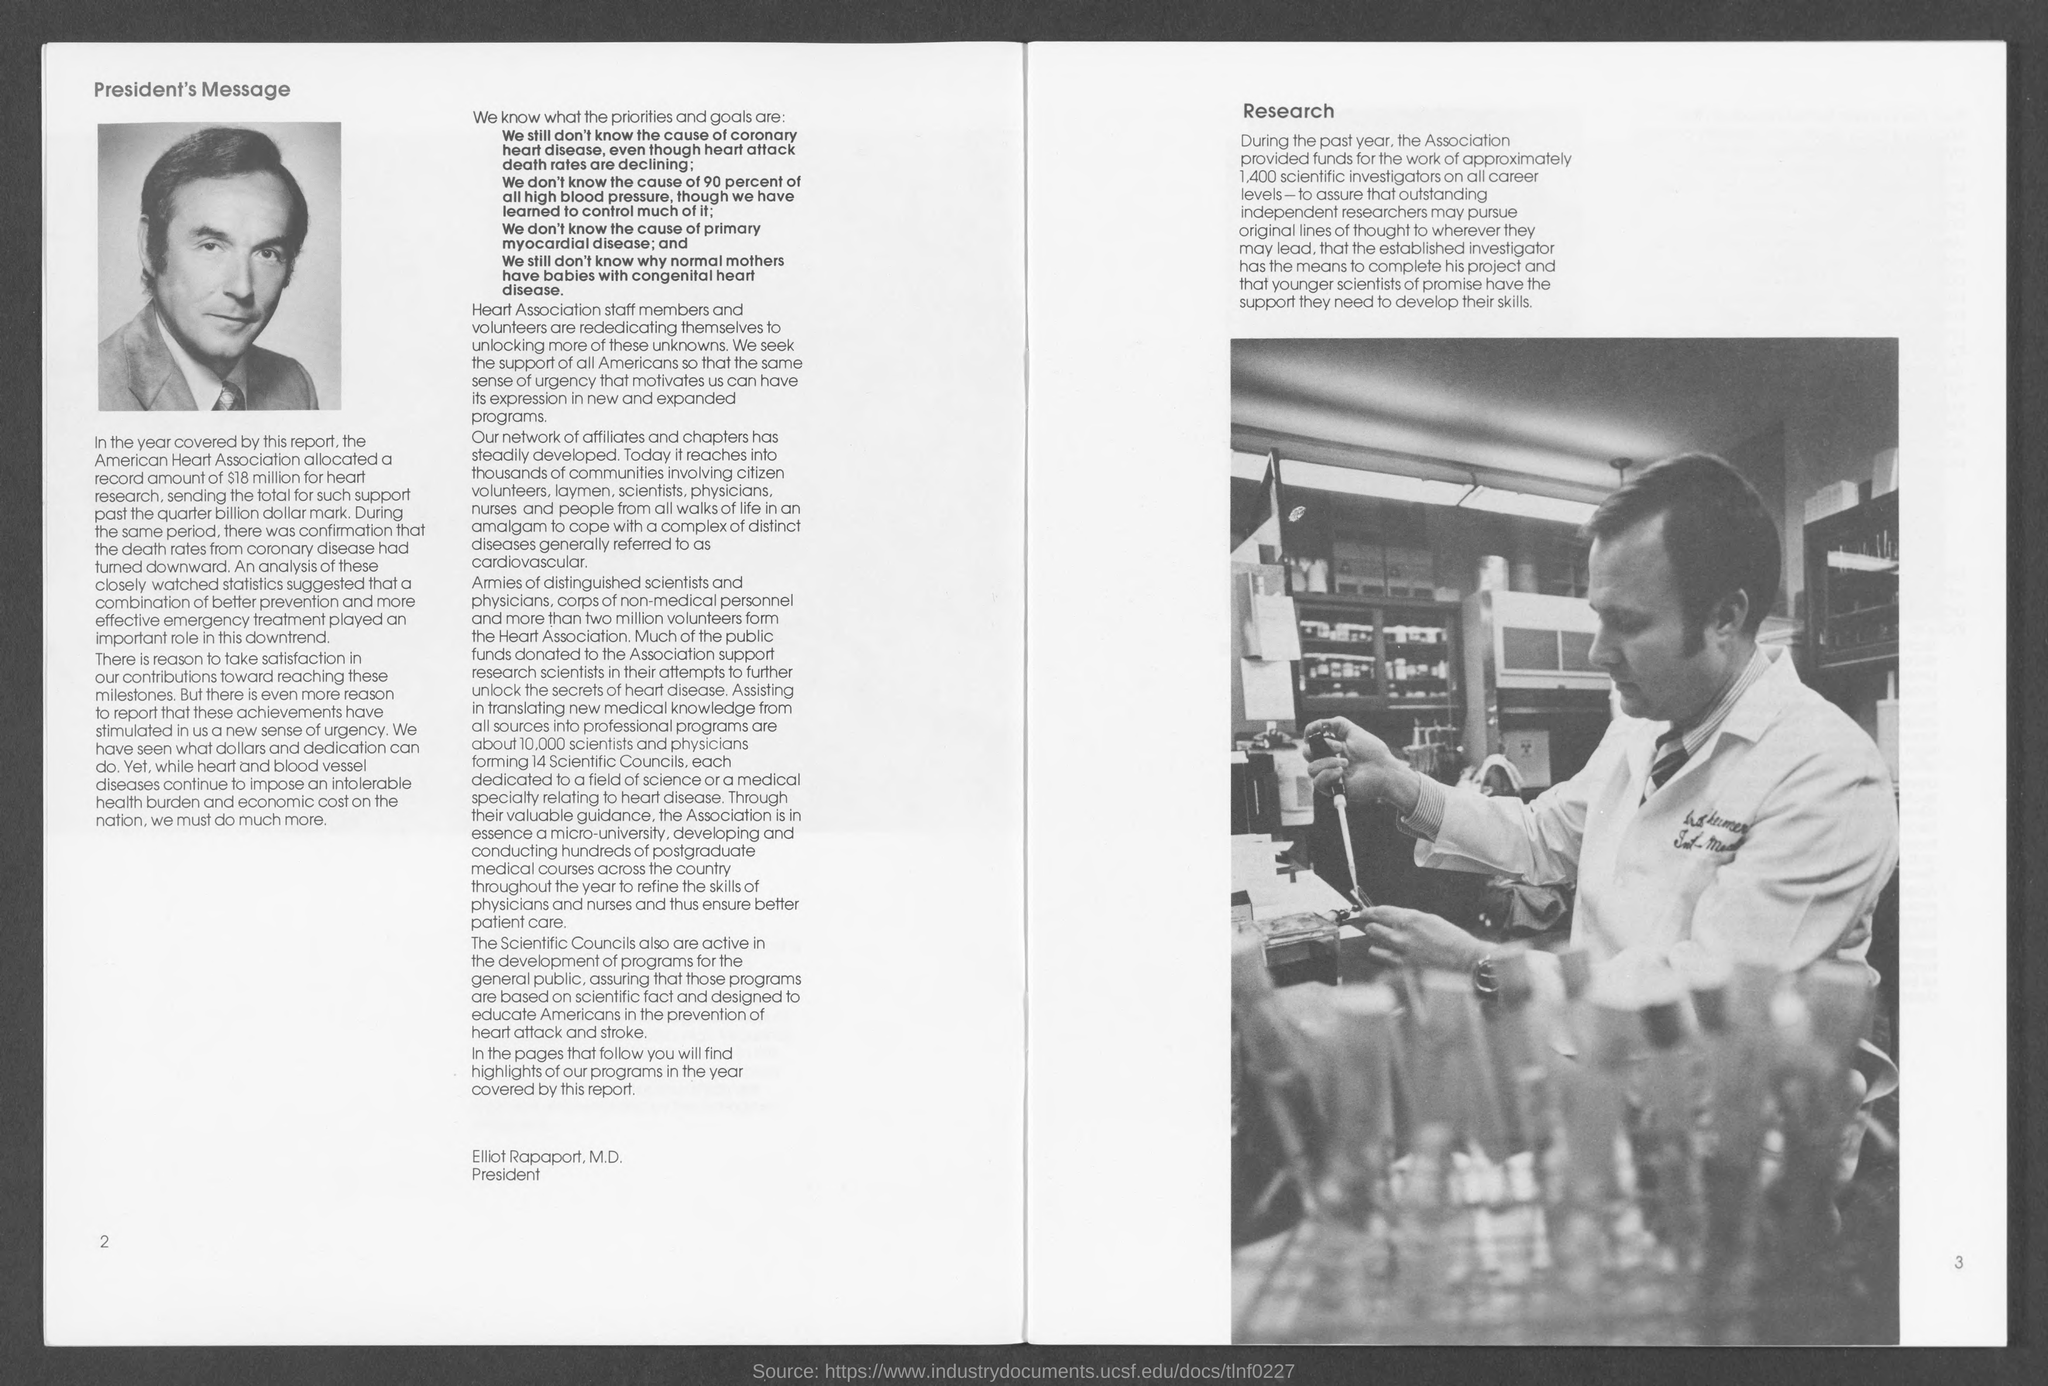Mention a couple of crucial points in this snapshot. The position of Elliot Rapaport, M.D. is that of president. The number at the bottom left side is 2. The number at the bottom right side is 3. 